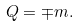Convert formula to latex. <formula><loc_0><loc_0><loc_500><loc_500>Q = \mp m .</formula> 